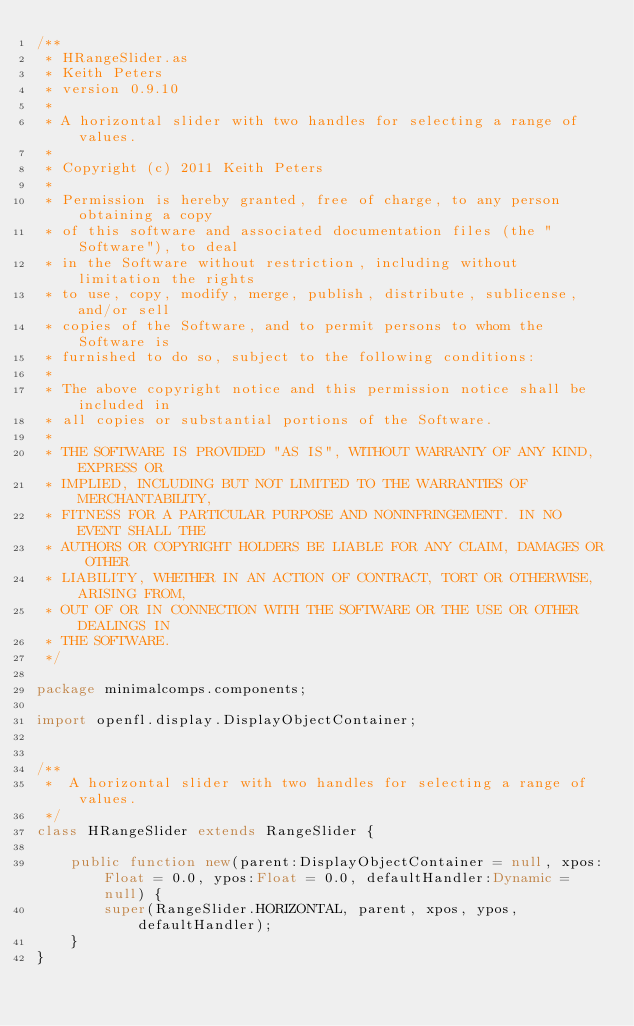Convert code to text. <code><loc_0><loc_0><loc_500><loc_500><_Haxe_>/**
 * HRangeSlider.as
 * Keith Peters
 * version 0.9.10
 * 
 * A horizontal slider with two handles for selecting a range of values.
 * 
 * Copyright (c) 2011 Keith Peters
 * 
 * Permission is hereby granted, free of charge, to any person obtaining a copy
 * of this software and associated documentation files (the "Software"), to deal
 * in the Software without restriction, including without limitation the rights
 * to use, copy, modify, merge, publish, distribute, sublicense, and/or sell
 * copies of the Software, and to permit persons to whom the Software is
 * furnished to do so, subject to the following conditions:
 * 
 * The above copyright notice and this permission notice shall be included in
 * all copies or substantial portions of the Software.
 * 
 * THE SOFTWARE IS PROVIDED "AS IS", WITHOUT WARRANTY OF ANY KIND, EXPRESS OR
 * IMPLIED, INCLUDING BUT NOT LIMITED TO THE WARRANTIES OF MERCHANTABILITY,
 * FITNESS FOR A PARTICULAR PURPOSE AND NONINFRINGEMENT. IN NO EVENT SHALL THE
 * AUTHORS OR COPYRIGHT HOLDERS BE LIABLE FOR ANY CLAIM, DAMAGES OR OTHER
 * LIABILITY, WHETHER IN AN ACTION OF CONTRACT, TORT OR OTHERWISE, ARISING FROM,
 * OUT OF OR IN CONNECTION WITH THE SOFTWARE OR THE USE OR OTHER DEALINGS IN
 * THE SOFTWARE.
 */

package minimalcomps.components;

import openfl.display.DisplayObjectContainer;


/**
 *  A horizontal slider with two handles for selecting a range of values.
 */
class HRangeSlider extends RangeSlider {

    public function new(parent:DisplayObjectContainer = null, xpos:Float = 0.0, ypos:Float = 0.0, defaultHandler:Dynamic = null) {
        super(RangeSlider.HORIZONTAL, parent, xpos, ypos, defaultHandler);
    }
}
</code> 